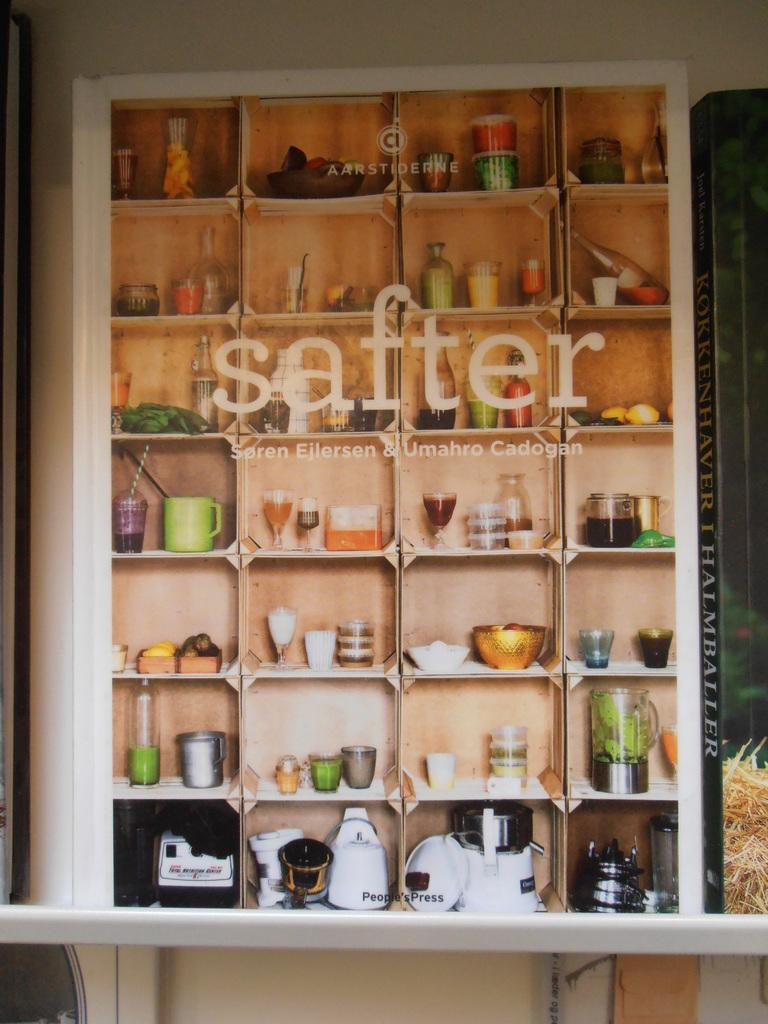Provide a one-sentence caption for the provided image. Varius small objects are on display in a cabinet with Safter and other workds etched on the glass. 